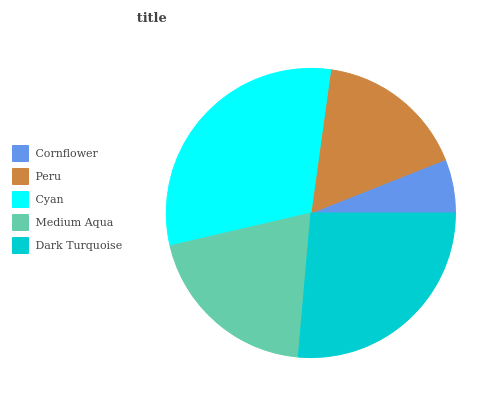Is Cornflower the minimum?
Answer yes or no. Yes. Is Cyan the maximum?
Answer yes or no. Yes. Is Peru the minimum?
Answer yes or no. No. Is Peru the maximum?
Answer yes or no. No. Is Peru greater than Cornflower?
Answer yes or no. Yes. Is Cornflower less than Peru?
Answer yes or no. Yes. Is Cornflower greater than Peru?
Answer yes or no. No. Is Peru less than Cornflower?
Answer yes or no. No. Is Medium Aqua the high median?
Answer yes or no. Yes. Is Medium Aqua the low median?
Answer yes or no. Yes. Is Cyan the high median?
Answer yes or no. No. Is Cyan the low median?
Answer yes or no. No. 